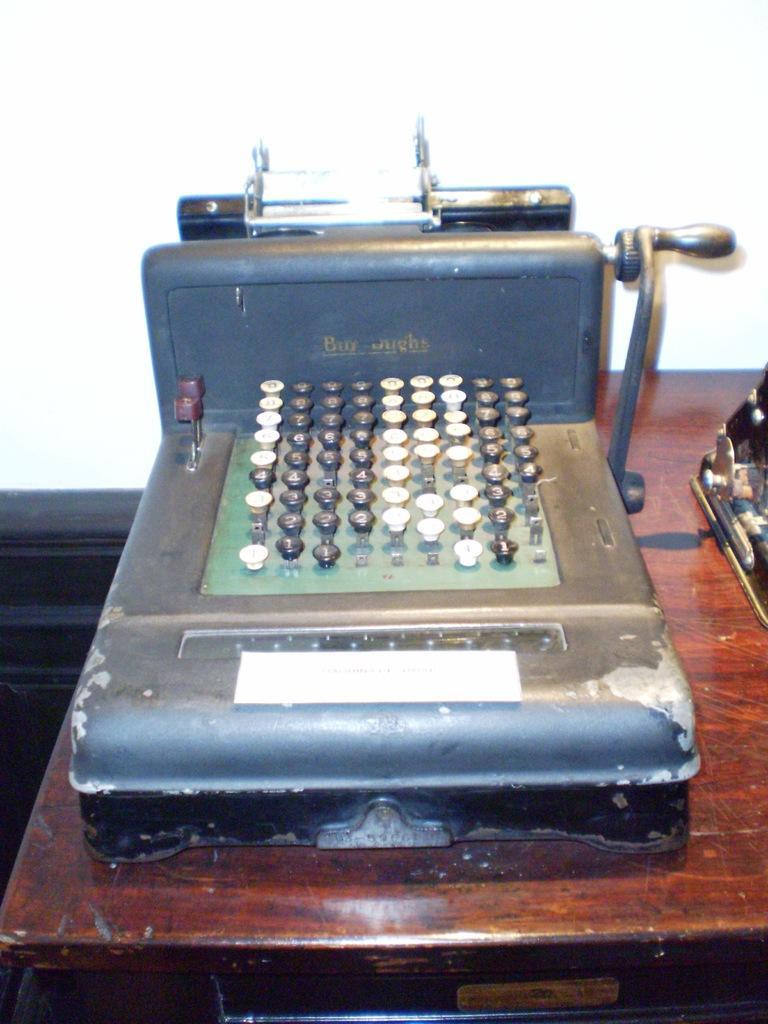In one or two sentences, can you explain what this image depicts? At the bottom of the image there is table, on the table there is a machine. At the top of the image there is wall. 